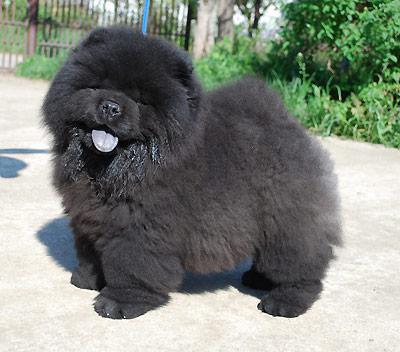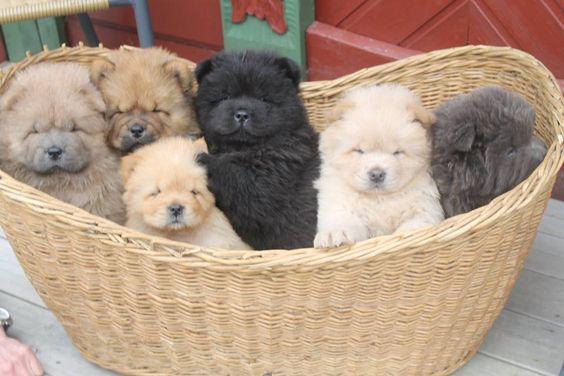The first image is the image on the left, the second image is the image on the right. Given the left and right images, does the statement "There are more chow dogs in the image on the right." hold true? Answer yes or no. Yes. 